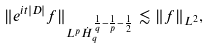Convert formula to latex. <formula><loc_0><loc_0><loc_500><loc_500>\| e ^ { i t | D | } f \| _ { L ^ { p } \dot { H } _ { q } ^ { \frac { 1 } { q } - \frac { 1 } { p } - \frac { 1 } { 2 } } } \lesssim \| f \| _ { L ^ { 2 } } ,</formula> 